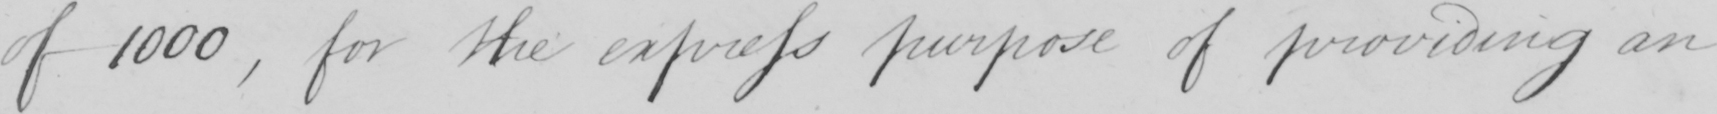Transcribe the text shown in this historical manuscript line. of 1000 , for the express purpose of providing an 